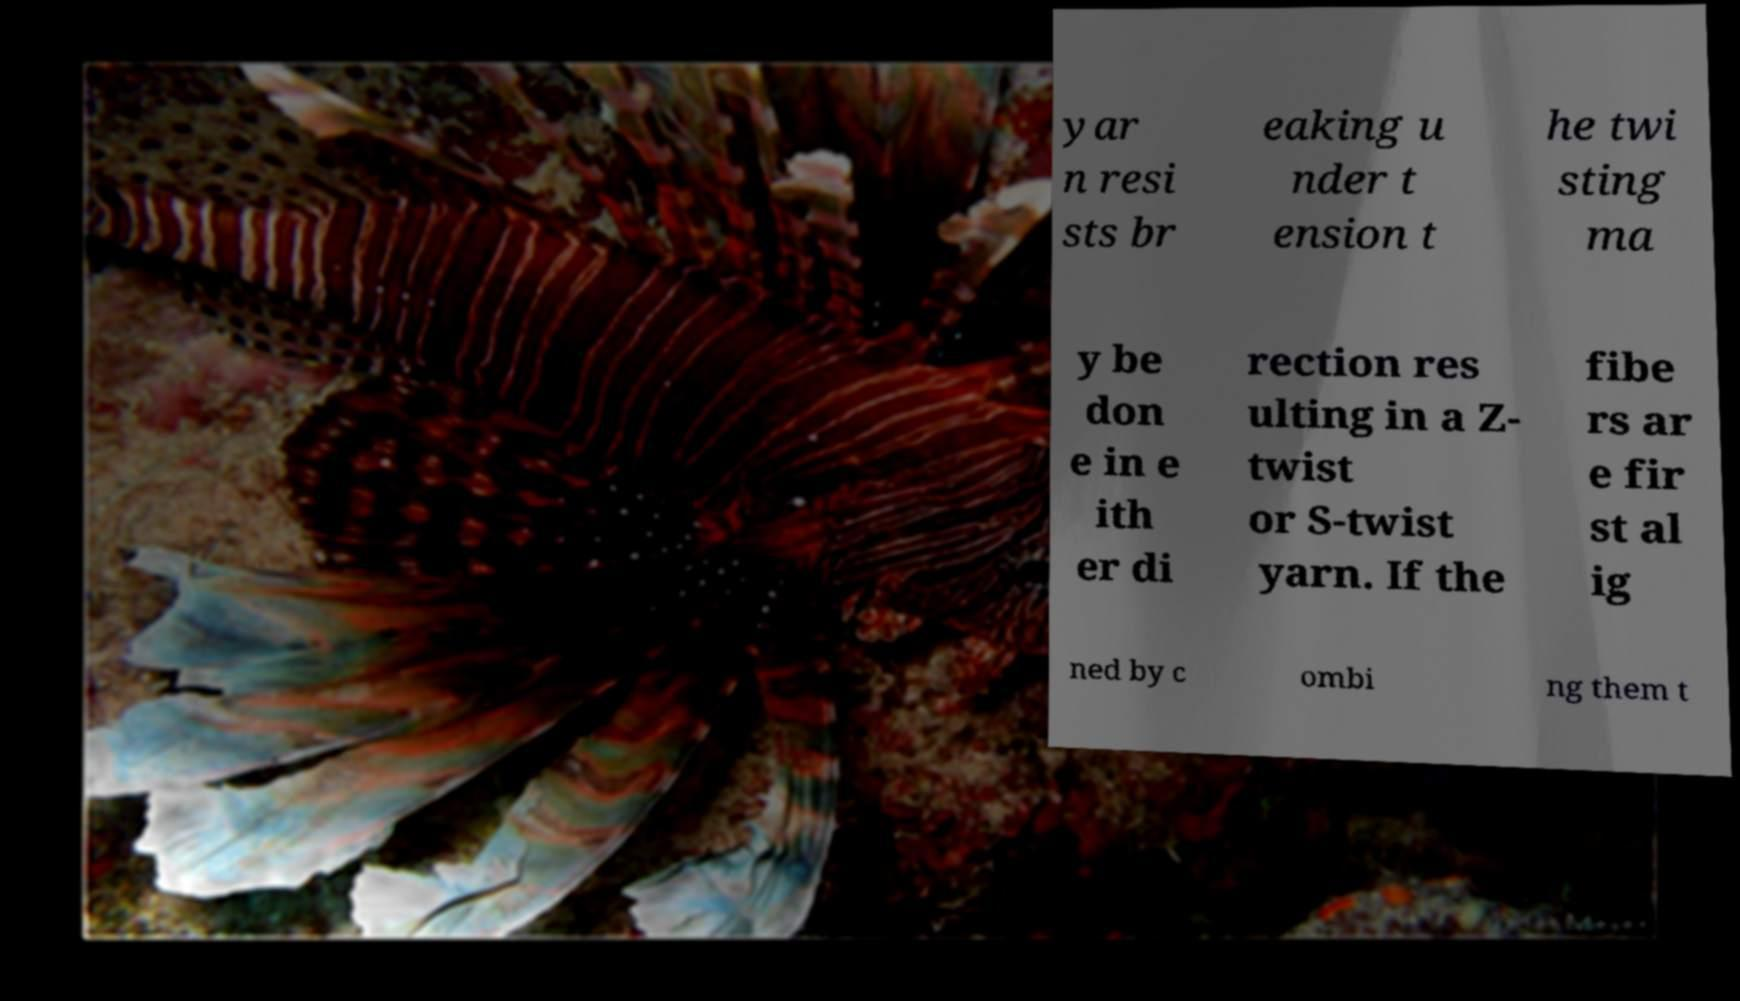Could you assist in decoding the text presented in this image and type it out clearly? yar n resi sts br eaking u nder t ension t he twi sting ma y be don e in e ith er di rection res ulting in a Z- twist or S-twist yarn. If the fibe rs ar e fir st al ig ned by c ombi ng them t 